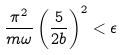Convert formula to latex. <formula><loc_0><loc_0><loc_500><loc_500>\frac { \pi ^ { 2 } } { m \omega } \left ( \frac { 5 } { 2 b } \right ) ^ { 2 } < \epsilon</formula> 